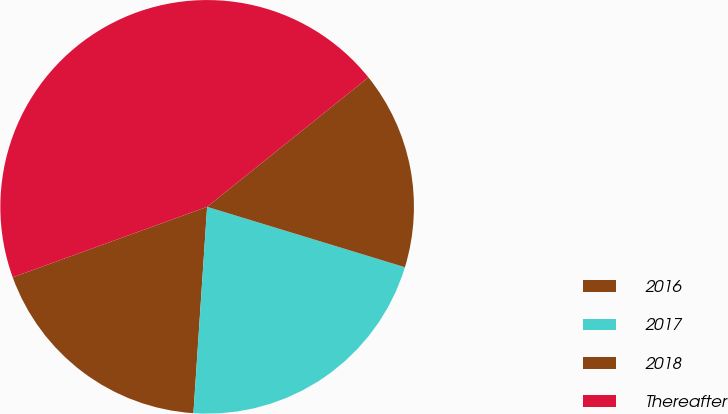Convert chart to OTSL. <chart><loc_0><loc_0><loc_500><loc_500><pie_chart><fcel>2016<fcel>2017<fcel>2018<fcel>Thereafter<nl><fcel>18.41%<fcel>21.34%<fcel>15.48%<fcel>44.77%<nl></chart> 